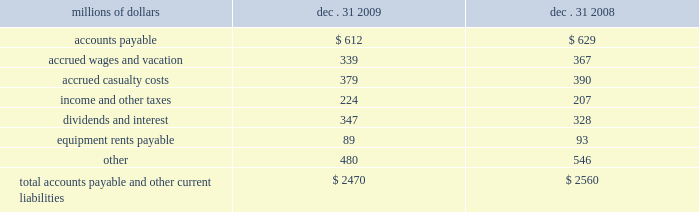Unusual , ( ii ) is material in amount , and ( iii ) varies significantly from the retirement profile identified through our depreciation studies .
A gain or loss is recognized in other income when we sell land or dispose of assets that are not part of our railroad operations .
When we purchase an asset , we capitalize all costs necessary to make the asset ready for its intended use .
However , many of our assets are self-constructed .
A large portion of our capital expenditures is for replacement of existing road infrastructure assets ( program projects ) , which is typically performed by our employees , and for track line expansion ( capacity projects ) .
Costs that are directly attributable or overhead costs that relate directly to capital projects are capitalized .
Direct costs that are capitalized as part of self-constructed assets include material , labor , and work equipment .
Indirect costs are capitalized if they clearly relate to the construction of the asset .
These costs are allocated using appropriate statistical bases .
General and administrative expenditures are expensed as incurred .
Normal repairs and maintenance are also expensed as incurred , while costs incurred that extend the useful life of an asset , improve the safety of our operations or improve operating efficiency are capitalized .
Assets held under capital leases are recorded at the lower of the net present value of the minimum lease payments or the fair value of the leased asset at the inception of the lease .
Amortization expense is computed using the straight-line method over the shorter of the estimated useful lives of the assets or the period of the related lease .
11 .
Accounts payable and other current liabilities dec .
31 , dec .
31 , millions of dollars 2009 2008 .
12 .
Financial instruments strategy and risk 2013 we may use derivative financial instruments in limited instances for other than trading purposes to assist in managing our overall exposure to fluctuations in interest rates and fuel prices .
We are not a party to leveraged derivatives and , by policy , do not use derivative financial instruments for speculative purposes .
Derivative financial instruments qualifying for hedge accounting must maintain a specified level of effectiveness between the hedging instrument and the item being hedged , both at inception and throughout the hedged period .
We formally document the nature and relationships between the hedging instruments and hedged items at inception , as well as our risk-management objectives , strategies for undertaking the various hedge transactions , and method of assessing hedge effectiveness .
Changes in the fair market value of derivative financial instruments that do not qualify for hedge accounting are charged to earnings .
We may use swaps , collars , futures , and/or forward contracts to mitigate the risk of adverse movements in interest rates and fuel prices ; however , the use of these derivative financial instruments may limit future benefits from favorable interest rate and fuel price movements. .
What was the change in equipment rents payable in millions from 2008 to 2009? 
Computations: (89 - 93)
Answer: -4.0. 